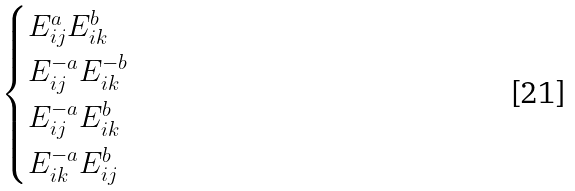<formula> <loc_0><loc_0><loc_500><loc_500>\begin{cases} E _ { i j } ^ { a } E _ { i k } ^ { b } \\ E _ { i j } ^ { - a } E _ { i k } ^ { - b } \\ E _ { i j } ^ { - a } E _ { i k } ^ { b } \\ E _ { i k } ^ { - a } E _ { i j } ^ { b } \\ \end{cases}</formula> 